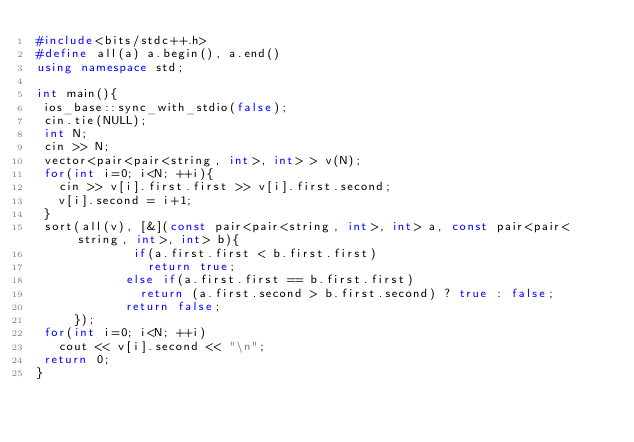<code> <loc_0><loc_0><loc_500><loc_500><_C++_>#include<bits/stdc++.h>
#define all(a) a.begin(), a.end()
using namespace std;

int main(){
 ios_base::sync_with_stdio(false);
 cin.tie(NULL);
 int N;
 cin >> N;
 vector<pair<pair<string, int>, int> > v(N);
 for(int i=0; i<N; ++i){ 
   cin >> v[i].first.first >> v[i].first.second;
   v[i].second = i+1;
 }
 sort(all(v), [&](const pair<pair<string, int>, int> a, const pair<pair<string, int>, int> b){
             if(a.first.first < b.first.first)
               return true;
            else if(a.first.first == b.first.first)
              return (a.first.second > b.first.second) ? true : false;
            return false;
     });
 for(int i=0; i<N; ++i)
   cout << v[i].second << "\n";
 return 0;
}
</code> 